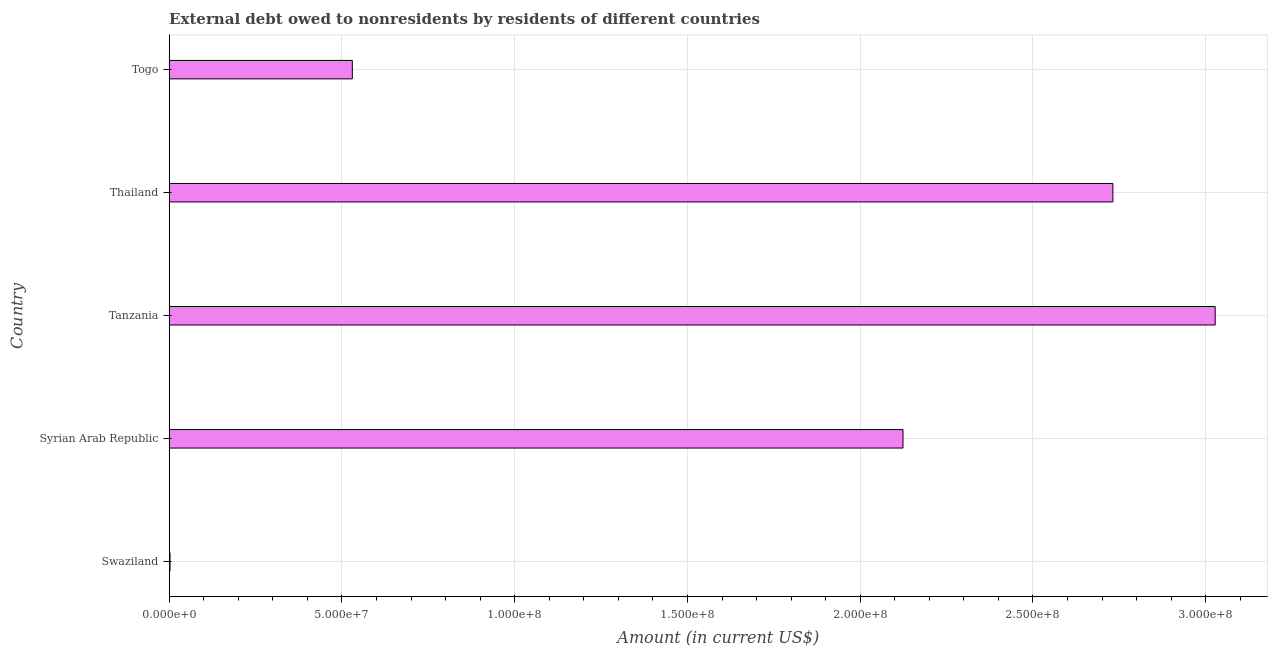Does the graph contain grids?
Give a very brief answer. Yes. What is the title of the graph?
Provide a succinct answer. External debt owed to nonresidents by residents of different countries. What is the label or title of the Y-axis?
Offer a very short reply. Country. Across all countries, what is the maximum debt?
Provide a succinct answer. 3.03e+08. In which country was the debt maximum?
Offer a very short reply. Tanzania. In which country was the debt minimum?
Keep it short and to the point. Swaziland. What is the sum of the debt?
Your response must be concise. 8.42e+08. What is the difference between the debt in Syrian Arab Republic and Thailand?
Your response must be concise. -6.07e+07. What is the average debt per country?
Offer a very short reply. 1.68e+08. What is the median debt?
Offer a terse response. 2.12e+08. What is the ratio of the debt in Syrian Arab Republic to that in Thailand?
Give a very brief answer. 0.78. Is the difference between the debt in Thailand and Togo greater than the difference between any two countries?
Offer a very short reply. No. What is the difference between the highest and the second highest debt?
Give a very brief answer. 2.96e+07. Is the sum of the debt in Swaziland and Syrian Arab Republic greater than the maximum debt across all countries?
Provide a short and direct response. No. What is the difference between the highest and the lowest debt?
Ensure brevity in your answer.  3.03e+08. In how many countries, is the debt greater than the average debt taken over all countries?
Your response must be concise. 3. How many bars are there?
Ensure brevity in your answer.  5. Are all the bars in the graph horizontal?
Your response must be concise. Yes. What is the Amount (in current US$) in Swaziland?
Make the answer very short. 2.40e+05. What is the Amount (in current US$) of Syrian Arab Republic?
Provide a short and direct response. 2.12e+08. What is the Amount (in current US$) in Tanzania?
Ensure brevity in your answer.  3.03e+08. What is the Amount (in current US$) in Thailand?
Ensure brevity in your answer.  2.73e+08. What is the Amount (in current US$) in Togo?
Ensure brevity in your answer.  5.30e+07. What is the difference between the Amount (in current US$) in Swaziland and Syrian Arab Republic?
Your answer should be compact. -2.12e+08. What is the difference between the Amount (in current US$) in Swaziland and Tanzania?
Make the answer very short. -3.03e+08. What is the difference between the Amount (in current US$) in Swaziland and Thailand?
Keep it short and to the point. -2.73e+08. What is the difference between the Amount (in current US$) in Swaziland and Togo?
Your response must be concise. -5.28e+07. What is the difference between the Amount (in current US$) in Syrian Arab Republic and Tanzania?
Offer a terse response. -9.04e+07. What is the difference between the Amount (in current US$) in Syrian Arab Republic and Thailand?
Give a very brief answer. -6.07e+07. What is the difference between the Amount (in current US$) in Syrian Arab Republic and Togo?
Provide a short and direct response. 1.59e+08. What is the difference between the Amount (in current US$) in Tanzania and Thailand?
Offer a terse response. 2.96e+07. What is the difference between the Amount (in current US$) in Tanzania and Togo?
Make the answer very short. 2.50e+08. What is the difference between the Amount (in current US$) in Thailand and Togo?
Provide a succinct answer. 2.20e+08. What is the ratio of the Amount (in current US$) in Swaziland to that in Syrian Arab Republic?
Provide a succinct answer. 0. What is the ratio of the Amount (in current US$) in Swaziland to that in Tanzania?
Give a very brief answer. 0. What is the ratio of the Amount (in current US$) in Swaziland to that in Togo?
Offer a terse response. 0.01. What is the ratio of the Amount (in current US$) in Syrian Arab Republic to that in Tanzania?
Keep it short and to the point. 0.7. What is the ratio of the Amount (in current US$) in Syrian Arab Republic to that in Thailand?
Your response must be concise. 0.78. What is the ratio of the Amount (in current US$) in Syrian Arab Republic to that in Togo?
Make the answer very short. 4.01. What is the ratio of the Amount (in current US$) in Tanzania to that in Thailand?
Provide a short and direct response. 1.11. What is the ratio of the Amount (in current US$) in Tanzania to that in Togo?
Give a very brief answer. 5.71. What is the ratio of the Amount (in current US$) in Thailand to that in Togo?
Your response must be concise. 5.15. 